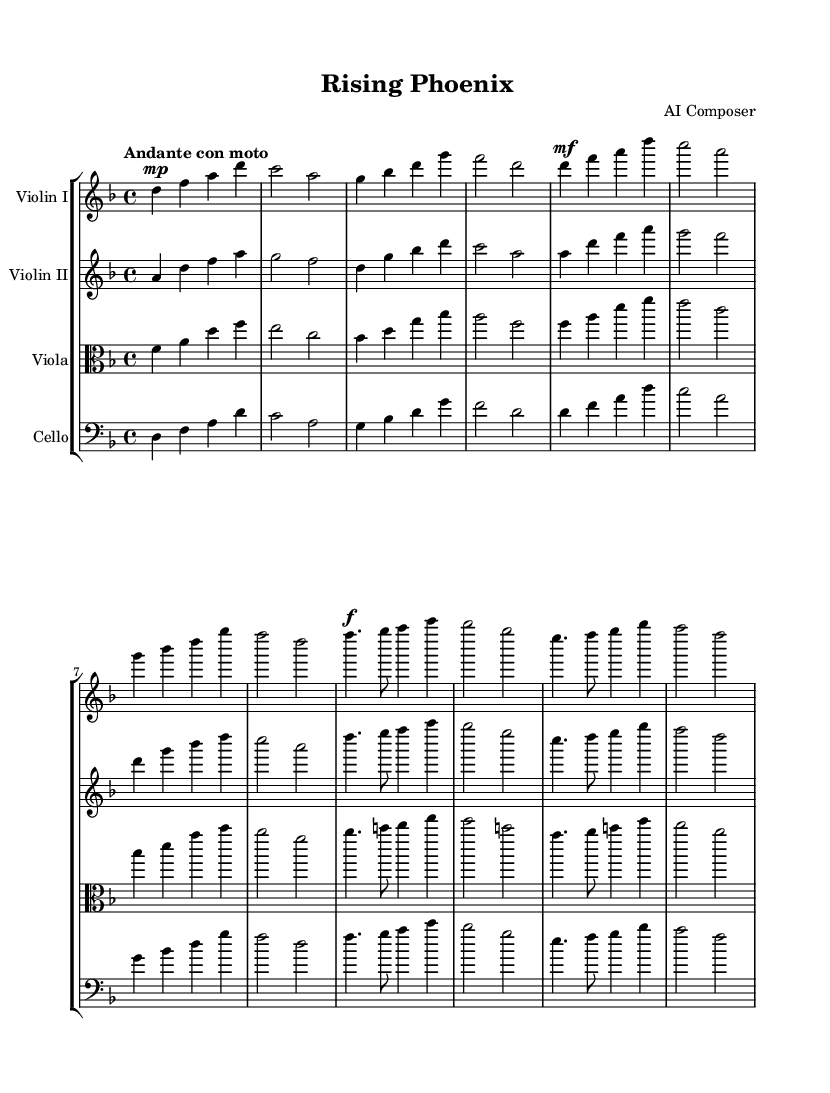What is the key signature of this music? The key signature of the piece indicates it is in D minor, which corresponds to one flat (B flat) in the key signature. This can be determined by inspecting the key signature notation at the beginning of the score.
Answer: D minor What is the time signature of this music? The time signature is present at the beginning of the score, indicated as 4/4. This means there are four beats in each measure and the quarter note gets one beat.
Answer: 4/4 What is the tempo marking of this piece? The tempo marking is written above the staff and reads "Andante con moto." This indicates a moderate pace, faster than Andante but still flowing.
Answer: Andante con moto How many measures are in the first part of the piece for Violin I? By counting the measures for Violin I in the first section, we find there are eight measures indicated before the repeat. This is a common structure for musical sections.
Answer: 8 measures Which instrument has the highest pitch in this symphonic composition? The highest pitch is found in Violin I, as violins generally have a higher range than viola and cello. The sheet music shows the highest notes are played by Violin I throughout the piece.
Answer: Violin I What dynamic marking is given to the first section of the music for all instruments? The first section is marked as "mp," indicating a mezzo-piano dynamic, which instructs the musicians to play moderately soft. This can be seen at the beginning of each instrument's part.
Answer: Mezzo-piano Which instrument plays the lowest tessitura in the piece? The cello, typically tuned lower than the other instruments, plays the lowest tessitura throughout the piece, which can be determined by analyzing the pitch range indicated in the cello staff.
Answer: Cello 